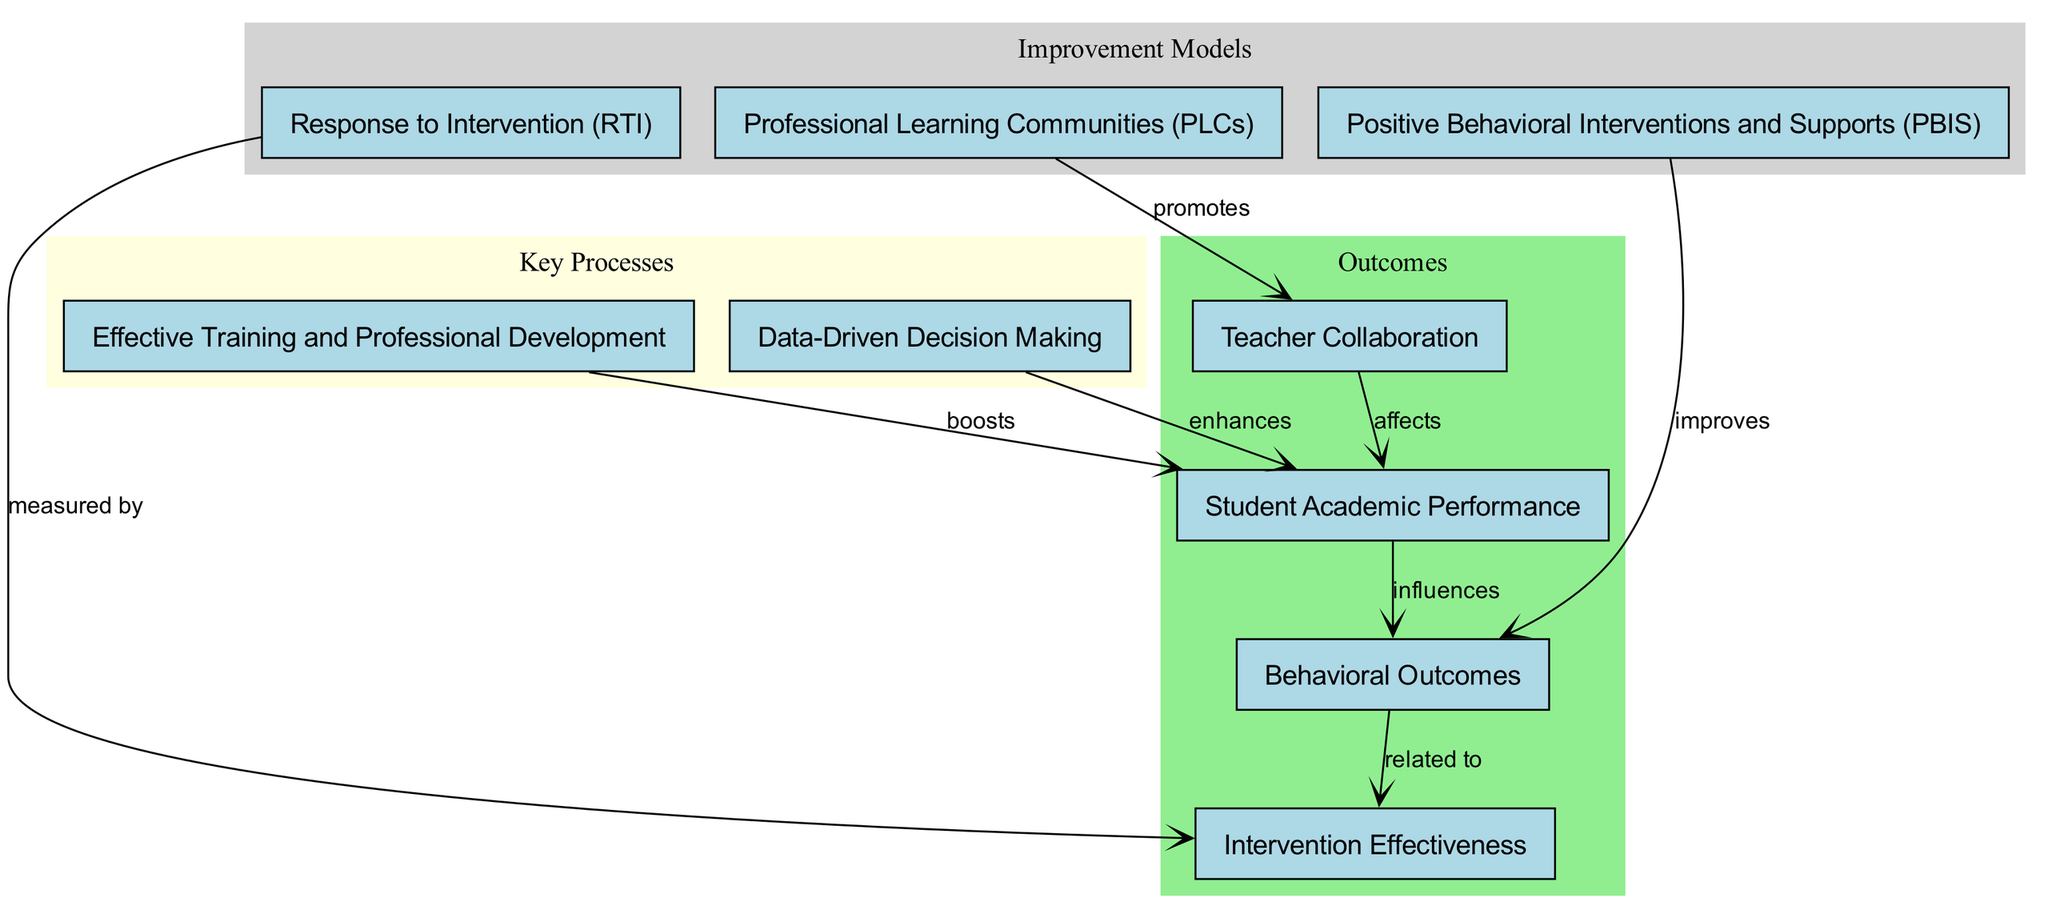What is the total number of nodes in the diagram? The diagram lists nodes for three school improvement models, two key processes, and four outcomes, adding up to a total of nine nodes.
Answer: 9 Which model promotes teacher collaboration? The arrow from the node "Professional Learning Communities (PLCs)" points to the node "Teacher Collaboration," indicating that PLCs promote this collaboration.
Answer: Professional Learning Communities (PLCs) What does the "Response to Intervention (RTI)" model measure? The edge labeled "measured by" connects "Response to Intervention (RTI)" to "Intervention Effectiveness," specifying what RTI measures.
Answer: Intervention Effectiveness How are "Student Academic Performance" and "Behavioral Outcomes" related? The diagram shows that "Student Academic Performance" influences "Behavioral Outcomes," indicating a directional relationship between these two outcomes.
Answer: influences What are the primary outcomes represented in the diagram? The outcomes listed are "Student Academic Performance," "Teacher Collaboration," "Behavioral Outcomes," and "Intervention Effectiveness," which categorize the results of the various models used.
Answer: Student Academic Performance, Teacher Collaboration, Behavioral Outcomes, Intervention Effectiveness Which interventions improve behavioral outcomes? The diagram indicates that "Positive Behavioral Interventions and Supports (PBIS)" improves "Behavioral Outcomes," establishing a cause-effect relationship.
Answer: Positive Behavioral Interventions and Supports (PBIS) How does "Data-Driven Decision Making" affect "Student Academic Performance"? The arrow labeled "enhances" linking "Data-Driven Decision Making" and "Student Academic Performance" indicates that the former contributes positively to the latter's outcomes.
Answer: enhances What is the connection between "Teacher Collaboration" and "Student Academic Performance"? The model illustrates that "Teacher Collaboration" affects "Student Academic Performance," highlighting the impact of collaboration on student outcomes.
Answer: affects What relationship does "Behavioral Outcomes" have with "Intervention Effectiveness"? "Behavioral Outcomes" is related to "Intervention Effectiveness" as shown by the edge labeled "related to," indicating that they share a connection.
Answer: related to 